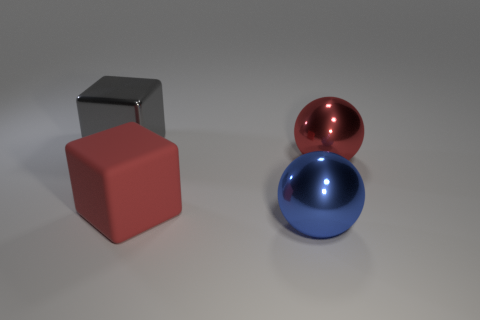Add 4 red blocks. How many objects exist? 8 Subtract all blue balls. How many balls are left? 1 Subtract all red cubes. Subtract all yellow balls. How many cubes are left? 1 Subtract all big shiny objects. Subtract all big brown rubber cylinders. How many objects are left? 1 Add 1 metal cubes. How many metal cubes are left? 2 Add 2 large blue metal things. How many large blue metal things exist? 3 Subtract 0 green cylinders. How many objects are left? 4 